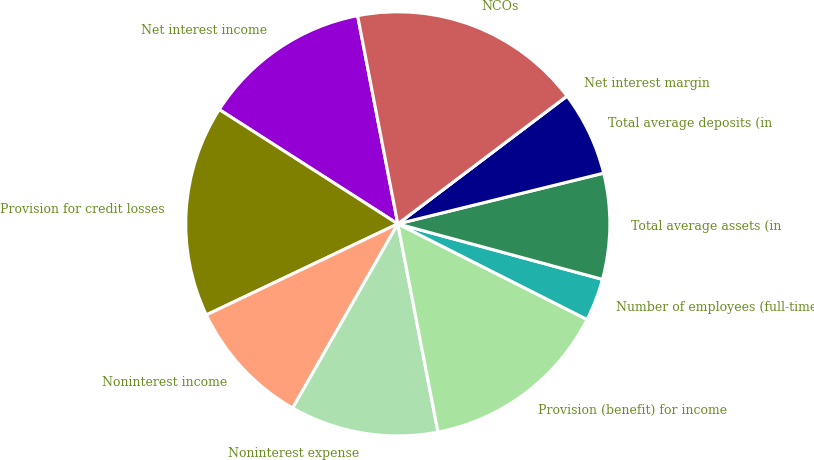Convert chart to OTSL. <chart><loc_0><loc_0><loc_500><loc_500><pie_chart><fcel>Net interest income<fcel>Provision for credit losses<fcel>Noninterest income<fcel>Noninterest expense<fcel>Provision (benefit) for income<fcel>Number of employees (full-time<fcel>Total average assets (in<fcel>Total average deposits (in<fcel>Net interest margin<fcel>NCOs<nl><fcel>12.9%<fcel>16.13%<fcel>9.68%<fcel>11.29%<fcel>14.52%<fcel>3.23%<fcel>8.06%<fcel>6.45%<fcel>0.0%<fcel>17.74%<nl></chart> 